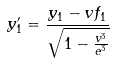Convert formula to latex. <formula><loc_0><loc_0><loc_500><loc_500>y _ { 1 } ^ { \prime } = \frac { y _ { 1 } - v f _ { 1 } } { \sqrt { 1 - \frac { v ^ { 3 } } { e ^ { 3 } } } }</formula> 